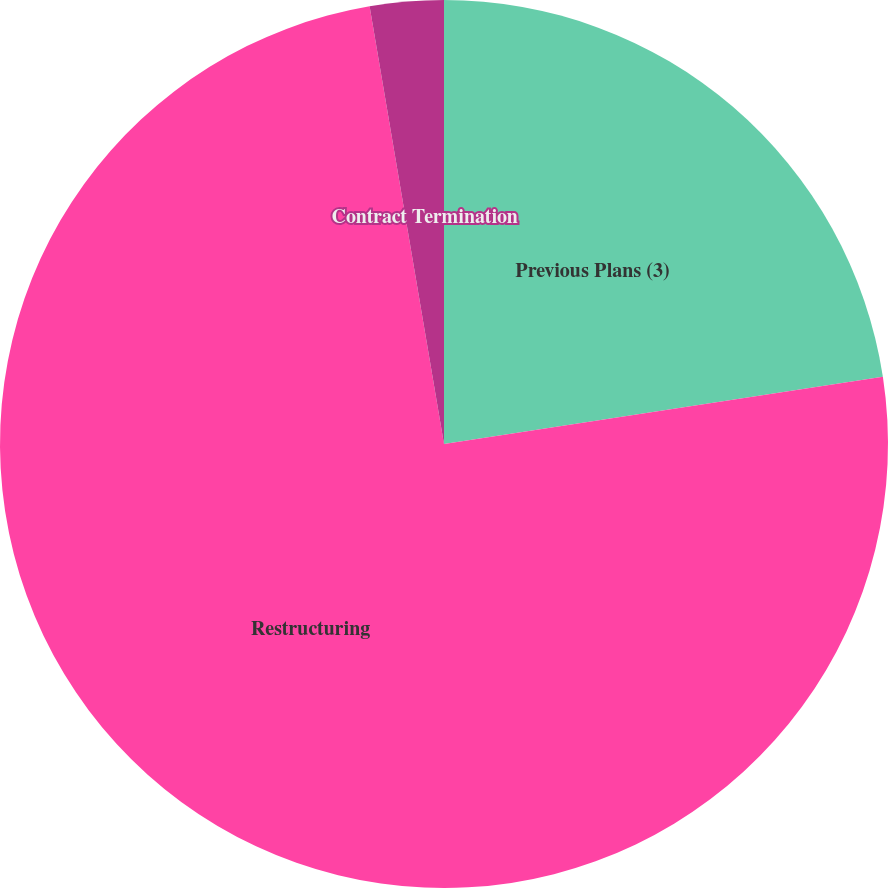Convert chart to OTSL. <chart><loc_0><loc_0><loc_500><loc_500><pie_chart><fcel>Previous Plans (3)<fcel>Restructuring<fcel>Contract Termination<nl><fcel>22.58%<fcel>74.74%<fcel>2.68%<nl></chart> 